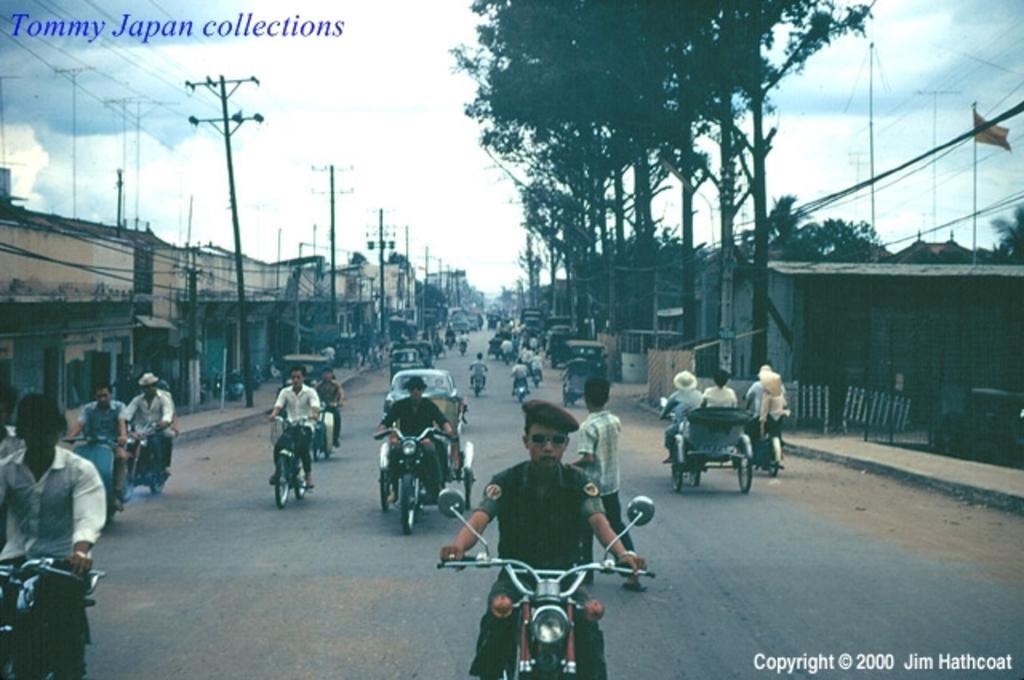Can you describe this image briefly? At the top we can see sky. These are current polls across the road and we can see trees, houses. We can see all the persons riding vehicles on the road. we can see one man is walking on the road. This is a flag. 